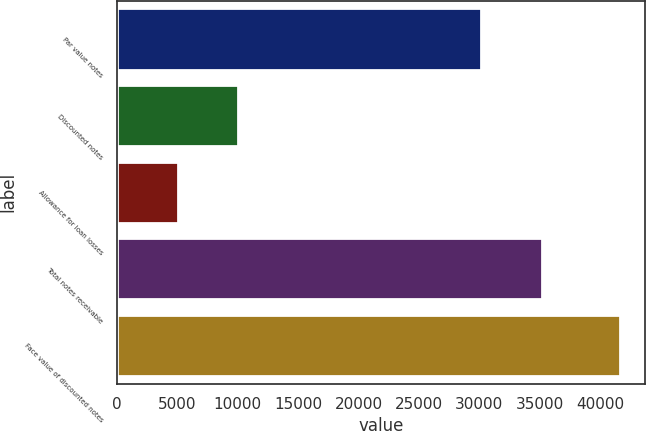<chart> <loc_0><loc_0><loc_500><loc_500><bar_chart><fcel>Par value notes<fcel>Discounted notes<fcel>Allowance for loan losses<fcel>Total notes receivable<fcel>Face value of discounted notes<nl><fcel>30155<fcel>10045<fcel>5014<fcel>35186<fcel>41668<nl></chart> 